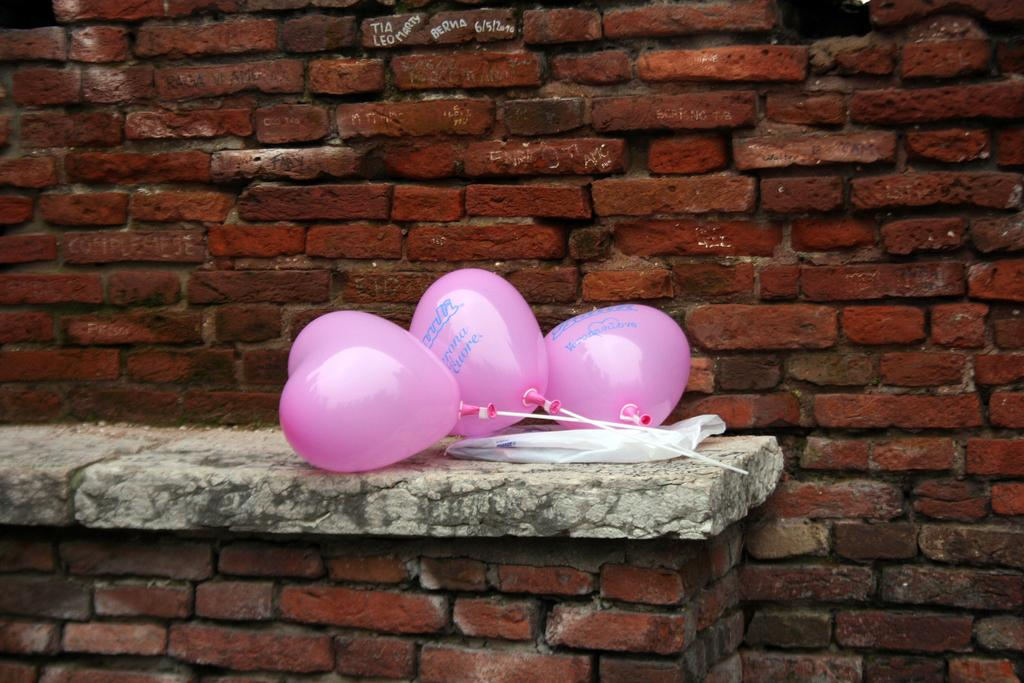What can be seen floating in the image? There are balloons in the image. What is on the wall in the image? There is a cover on the wall in the image. What is written on the balloons? There is text on the balloons. What can be seen in the distance in the image? There is a building visible in the background of the image. What is written on the wall in the background? There is text on the wall in the background. What type of coat is hanging on the wall in the image? There is no coat present in the image. What does the locket on the balloon say in the image? There is no locket present on the balloons in the image. 